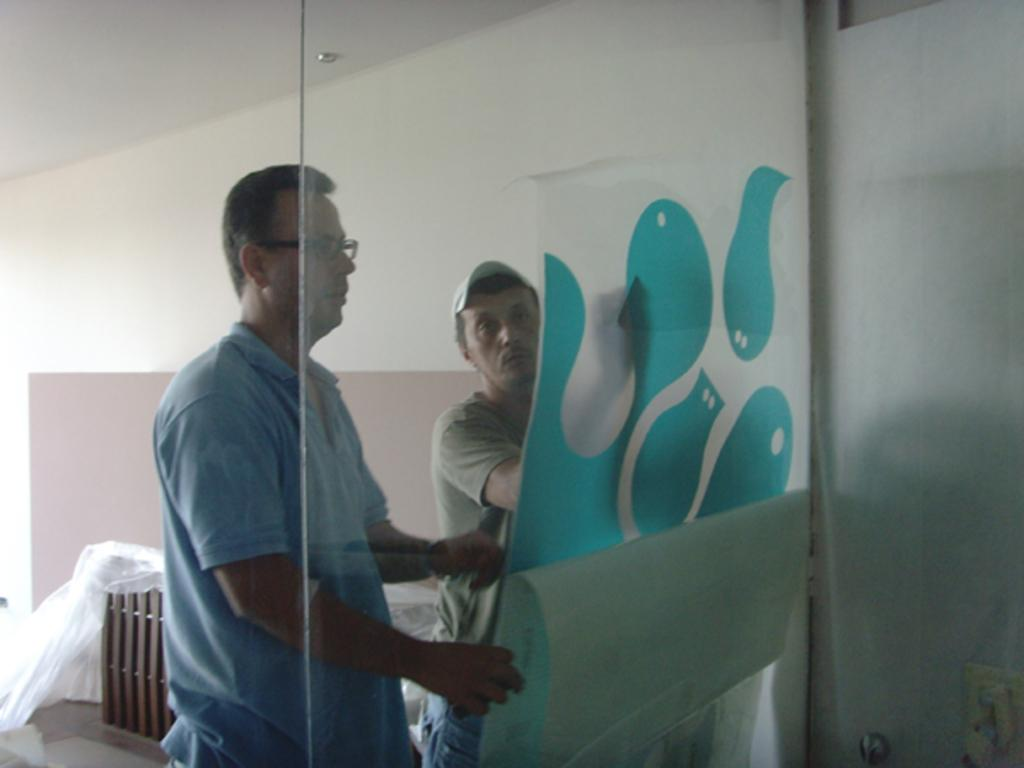Where was the image taken? The image was taken indoors. What can be seen in the center of the image? There are two persons in the center of the image. What are the persons wearing? The persons are wearing t-shirts. What are the persons holding? The persons are holding an object. What can be seen in the background of the image? There is a wall, a roof, and a wooden object in the background of the image. What type of juice is being served in the image? There is no juice present in the image. Can you see a horse in the image? No, there is no horse present in the image. 